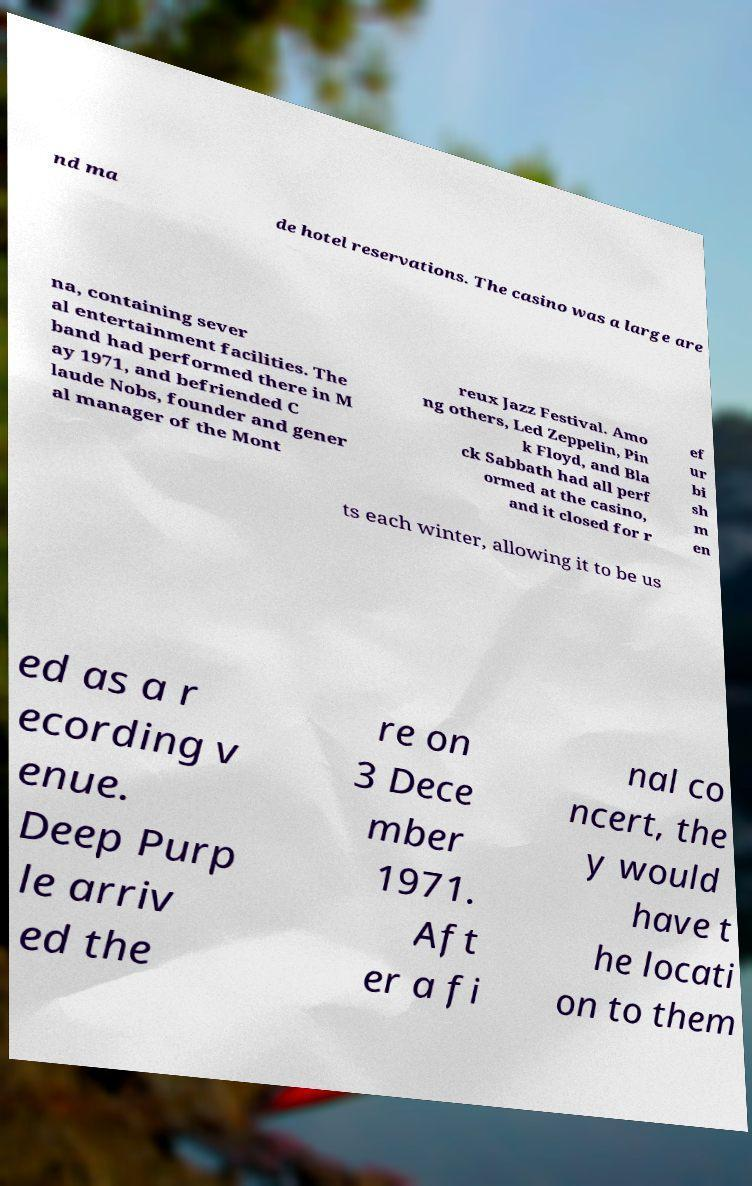What messages or text are displayed in this image? I need them in a readable, typed format. nd ma de hotel reservations. The casino was a large are na, containing sever al entertainment facilities. The band had performed there in M ay 1971, and befriended C laude Nobs, founder and gener al manager of the Mont reux Jazz Festival. Amo ng others, Led Zeppelin, Pin k Floyd, and Bla ck Sabbath had all perf ormed at the casino, and it closed for r ef ur bi sh m en ts each winter, allowing it to be us ed as a r ecording v enue. Deep Purp le arriv ed the re on 3 Dece mber 1971. Aft er a fi nal co ncert, the y would have t he locati on to them 